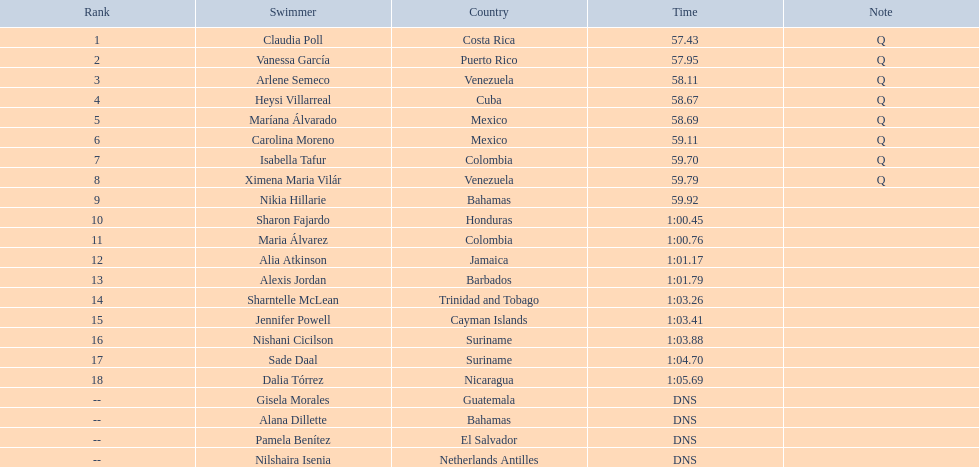Who finished after claudia poll? Vanessa García. 